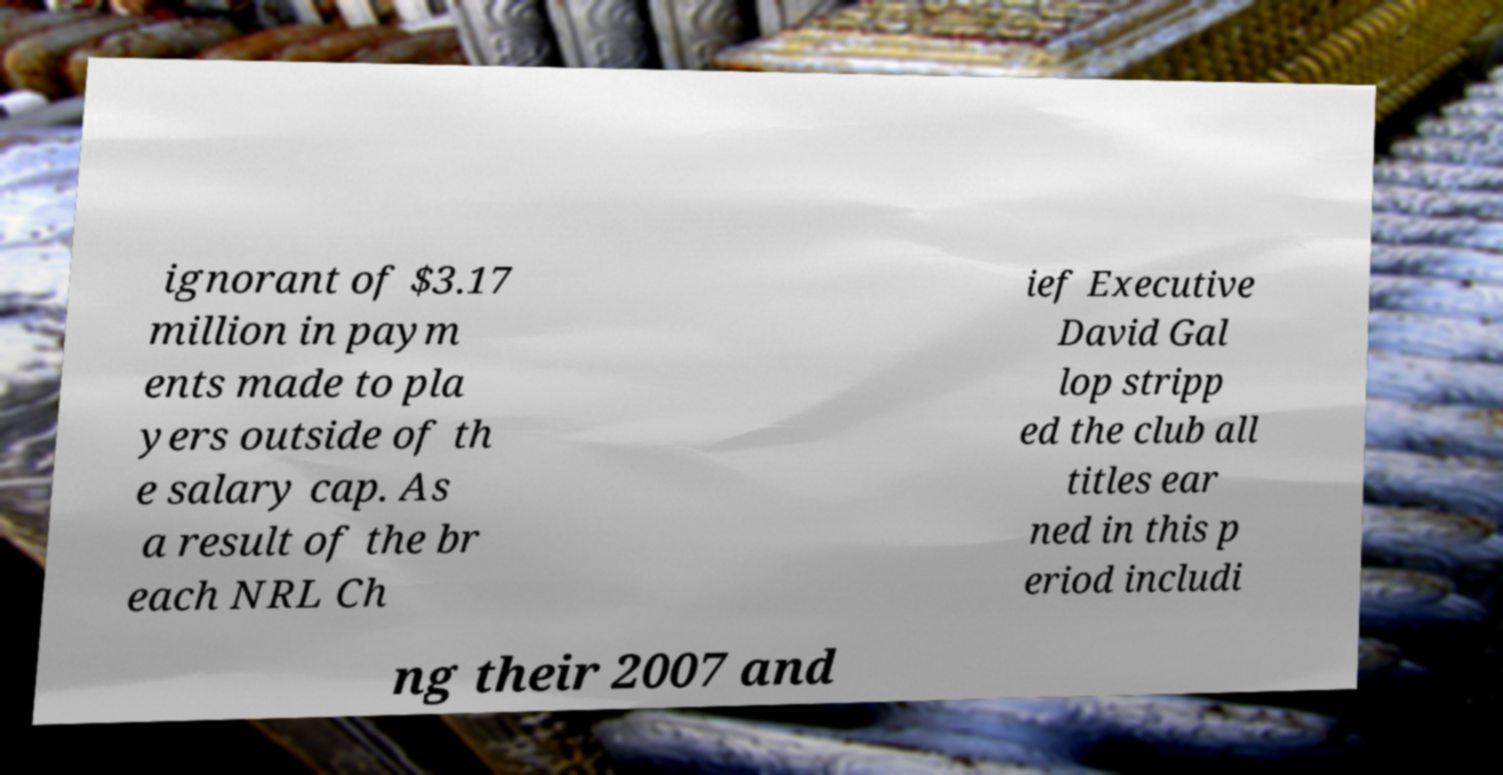Could you assist in decoding the text presented in this image and type it out clearly? ignorant of $3.17 million in paym ents made to pla yers outside of th e salary cap. As a result of the br each NRL Ch ief Executive David Gal lop stripp ed the club all titles ear ned in this p eriod includi ng their 2007 and 